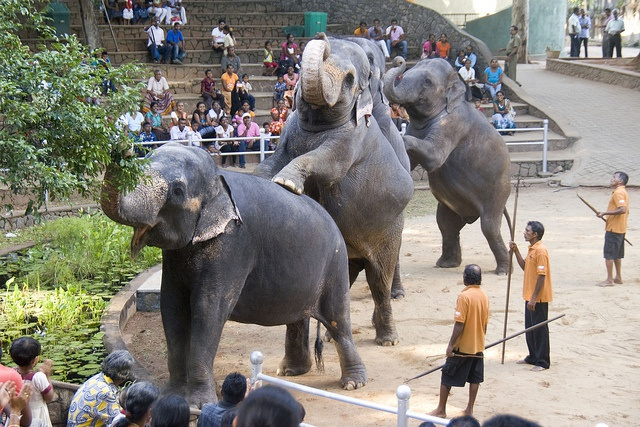Describe the objects in this image and their specific colors. I can see elephant in darkgreen, gray, black, and darkgray tones, elephant in darkgreen, gray, darkgray, black, and lightgray tones, people in darkgreen, gray, black, lavender, and darkgray tones, elephant in darkgreen, gray, and black tones, and people in darkgreen, black, tan, and gray tones in this image. 